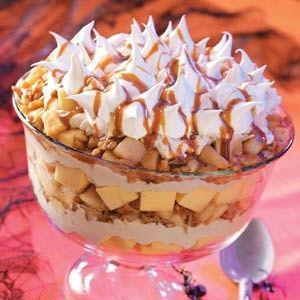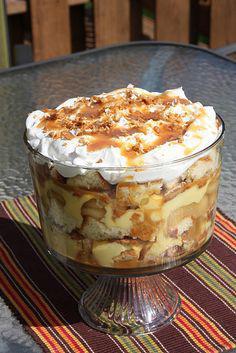The first image is the image on the left, the second image is the image on the right. Considering the images on both sides, is "There is caramel drizzled atop the desert in the image on the left." valid? Answer yes or no. Yes. The first image is the image on the left, the second image is the image on the right. Assess this claim about the two images: "Two large fancy layered desserts are in footed bowls.". Correct or not? Answer yes or no. Yes. 